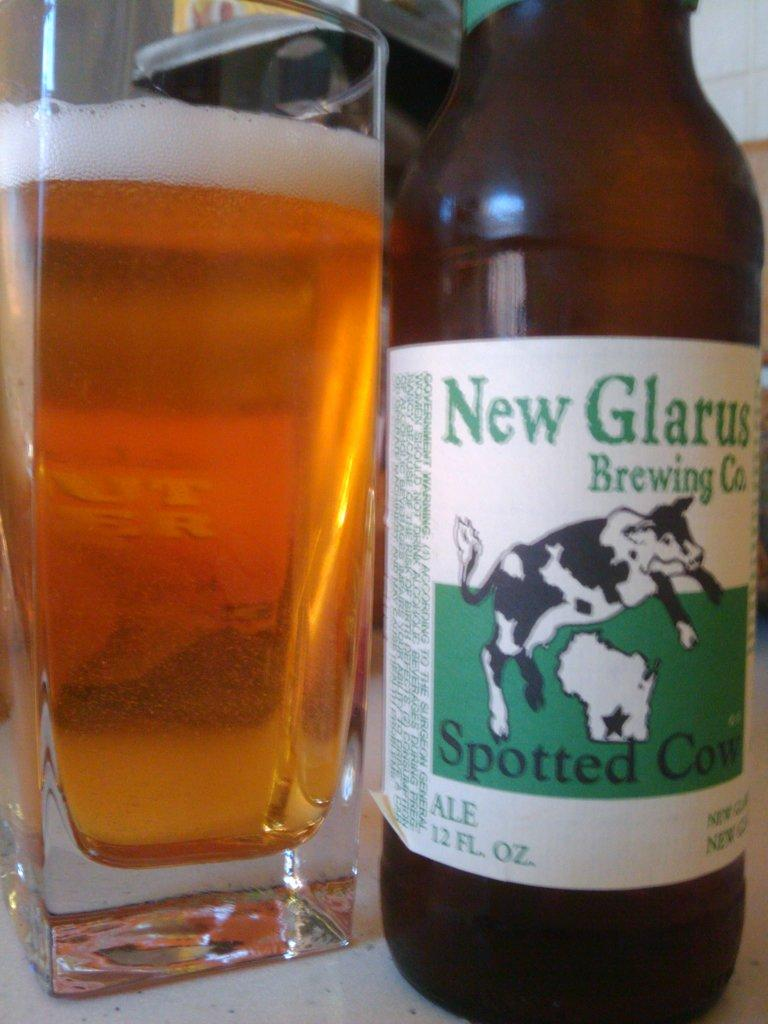<image>
Write a terse but informative summary of the picture. A spotted cow bottle of bear by New Glarus Brewing company. 